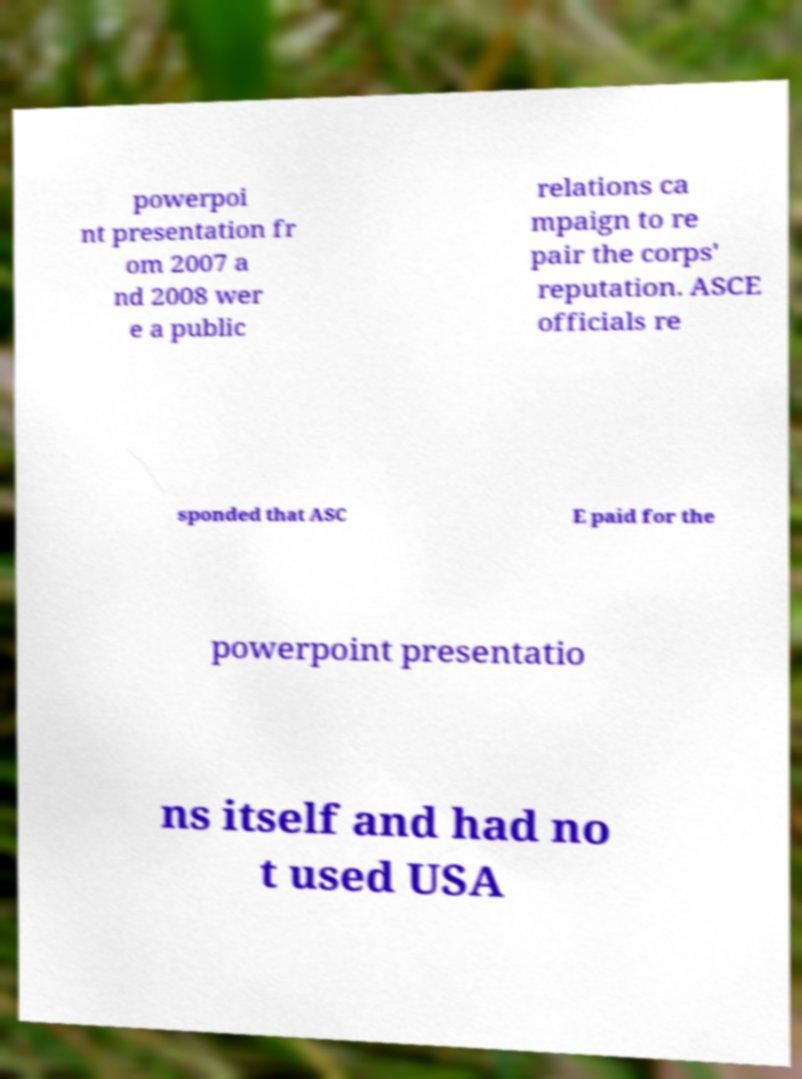Can you read and provide the text displayed in the image?This photo seems to have some interesting text. Can you extract and type it out for me? powerpoi nt presentation fr om 2007 a nd 2008 wer e a public relations ca mpaign to re pair the corps' reputation. ASCE officials re sponded that ASC E paid for the powerpoint presentatio ns itself and had no t used USA 